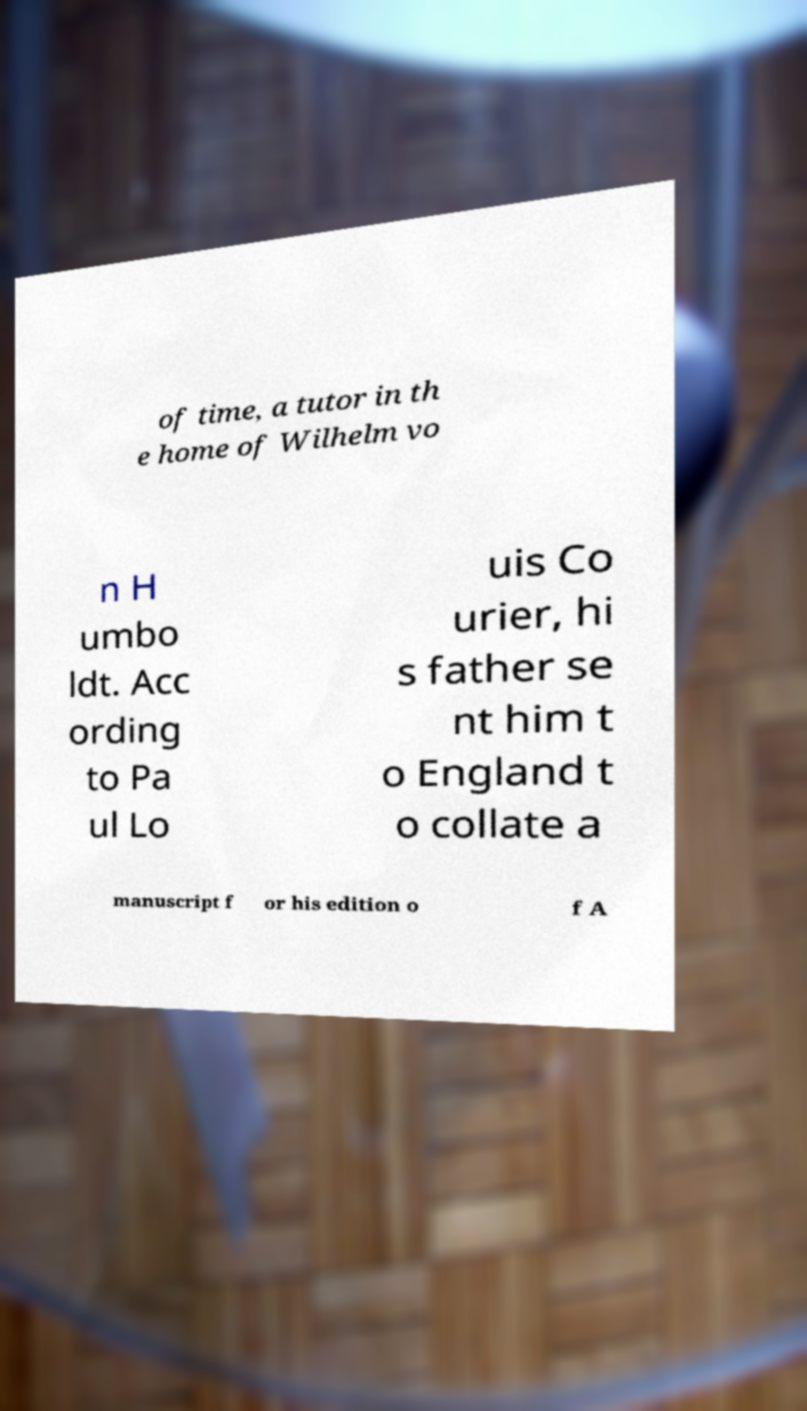Could you assist in decoding the text presented in this image and type it out clearly? of time, a tutor in th e home of Wilhelm vo n H umbo ldt. Acc ording to Pa ul Lo uis Co urier, hi s father se nt him t o England t o collate a manuscript f or his edition o f A 